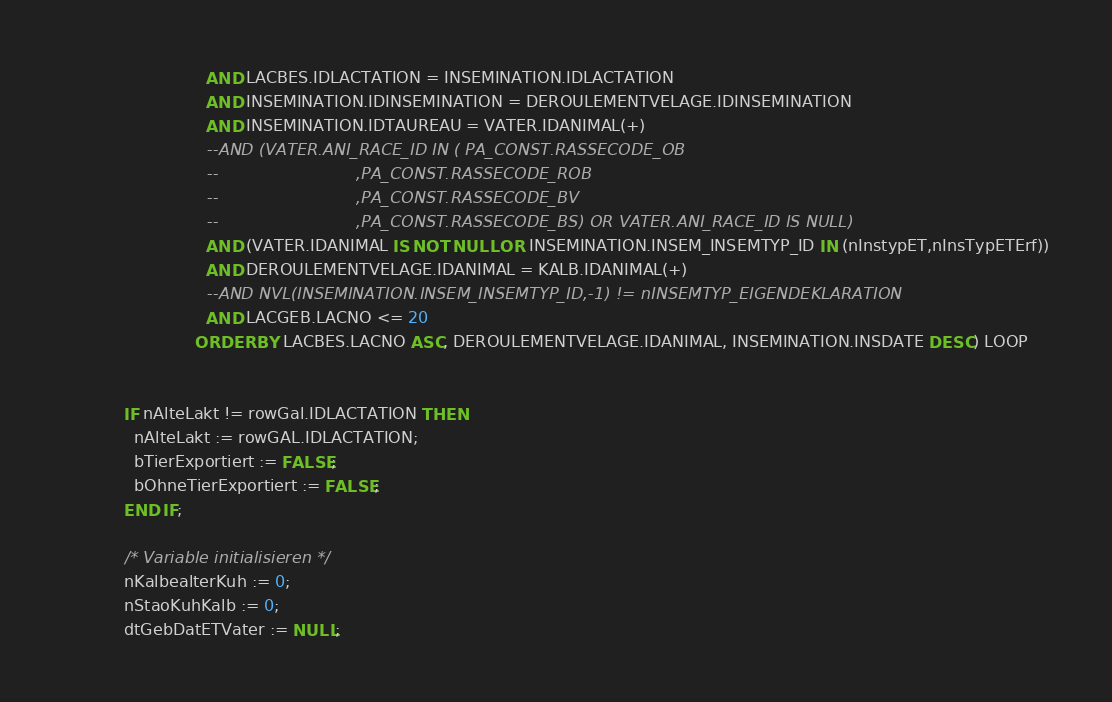<code> <loc_0><loc_0><loc_500><loc_500><_SQL_>                            AND LACBES.IDLACTATION = INSEMINATION.IDLACTATION
                            AND INSEMINATION.IDINSEMINATION = DEROULEMENTVELAGE.IDINSEMINATION
                            AND INSEMINATION.IDTAUREAU = VATER.IDANIMAL(+)
                            --AND (VATER.ANI_RACE_ID IN ( PA_CONST.RASSECODE_OB
                            --                           ,PA_CONST.RASSECODE_ROB
                            --                           ,PA_CONST.RASSECODE_BV
                            --                           ,PA_CONST.RASSECODE_BS) OR VATER.ANI_RACE_ID IS NULL)
                            AND (VATER.IDANIMAL IS NOT NULL OR INSEMINATION.INSEM_INSEMTYP_ID IN (nInstypET,nInsTypETErf))
                            AND DEROULEMENTVELAGE.IDANIMAL = KALB.IDANIMAL(+)
                            --AND NVL(INSEMINATION.INSEM_INSEMTYP_ID,-1) != nINSEMTYP_EIGENDEKLARATION
                            AND LACGEB.LACNO <= 20
                          ORDER BY LACBES.LACNO ASC, DEROULEMENTVELAGE.IDANIMAL, INSEMINATION.INSDATE DESC) LOOP


            IF nAlteLakt != rowGal.IDLACTATION THEN
              nAlteLakt := rowGAL.IDLACTATION;
              bTierExportiert := FALSE;
              bOhneTierExportiert := FALSE;
            END IF;

            /* Variable initialisieren */
            nKalbealterKuh := 0;
            nStaoKuhKalb := 0;
            dtGebDatETVater := NULL;</code> 